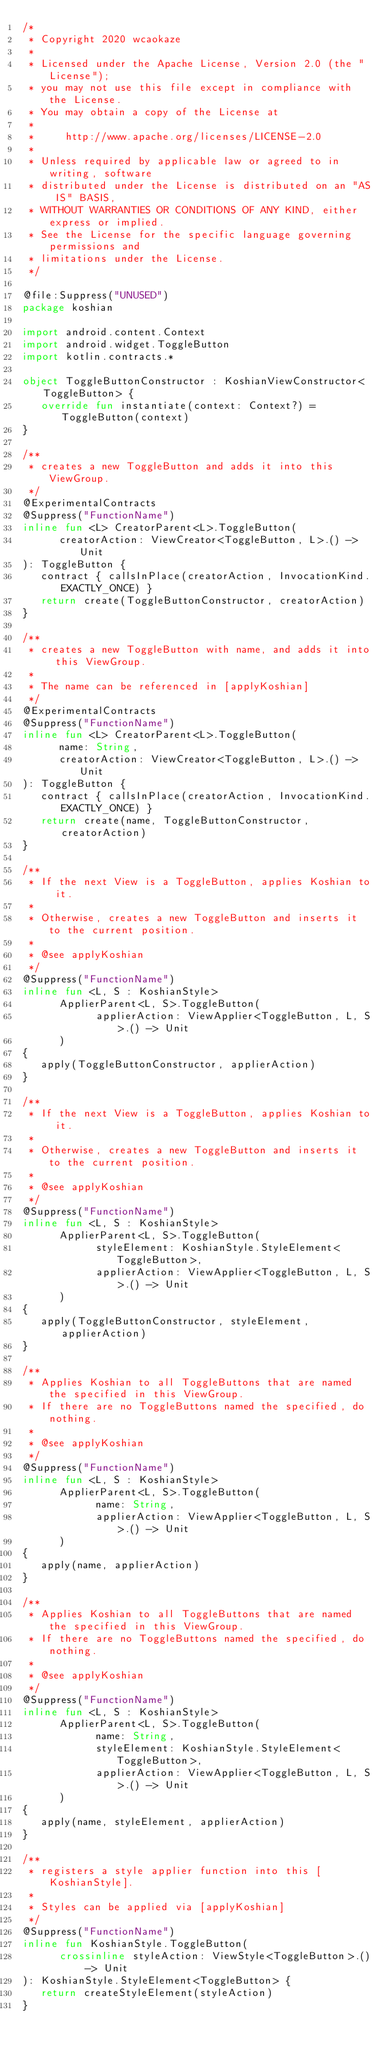<code> <loc_0><loc_0><loc_500><loc_500><_Kotlin_>/*
 * Copyright 2020 wcaokaze
 *
 * Licensed under the Apache License, Version 2.0 (the "License");
 * you may not use this file except in compliance with the License.
 * You may obtain a copy of the License at
 *
 *     http://www.apache.org/licenses/LICENSE-2.0
 *
 * Unless required by applicable law or agreed to in writing, software
 * distributed under the License is distributed on an "AS IS" BASIS,
 * WITHOUT WARRANTIES OR CONDITIONS OF ANY KIND, either express or implied.
 * See the License for the specific language governing permissions and
 * limitations under the License.
 */

@file:Suppress("UNUSED")
package koshian

import android.content.Context
import android.widget.ToggleButton
import kotlin.contracts.*

object ToggleButtonConstructor : KoshianViewConstructor<ToggleButton> {
   override fun instantiate(context: Context?) = ToggleButton(context)
}

/**
 * creates a new ToggleButton and adds it into this ViewGroup.
 */
@ExperimentalContracts
@Suppress("FunctionName")
inline fun <L> CreatorParent<L>.ToggleButton(
      creatorAction: ViewCreator<ToggleButton, L>.() -> Unit
): ToggleButton {
   contract { callsInPlace(creatorAction, InvocationKind.EXACTLY_ONCE) }
   return create(ToggleButtonConstructor, creatorAction)
}

/**
 * creates a new ToggleButton with name, and adds it into this ViewGroup.
 *
 * The name can be referenced in [applyKoshian]
 */
@ExperimentalContracts
@Suppress("FunctionName")
inline fun <L> CreatorParent<L>.ToggleButton(
      name: String,
      creatorAction: ViewCreator<ToggleButton, L>.() -> Unit
): ToggleButton {
   contract { callsInPlace(creatorAction, InvocationKind.EXACTLY_ONCE) }
   return create(name, ToggleButtonConstructor, creatorAction)
}

/**
 * If the next View is a ToggleButton, applies Koshian to it.
 *
 * Otherwise, creates a new ToggleButton and inserts it to the current position.
 *
 * @see applyKoshian
 */
@Suppress("FunctionName")
inline fun <L, S : KoshianStyle>
      ApplierParent<L, S>.ToggleButton(
            applierAction: ViewApplier<ToggleButton, L, S>.() -> Unit
      )
{
   apply(ToggleButtonConstructor, applierAction)
}

/**
 * If the next View is a ToggleButton, applies Koshian to it.
 *
 * Otherwise, creates a new ToggleButton and inserts it to the current position.
 *
 * @see applyKoshian
 */
@Suppress("FunctionName")
inline fun <L, S : KoshianStyle>
      ApplierParent<L, S>.ToggleButton(
            styleElement: KoshianStyle.StyleElement<ToggleButton>,
            applierAction: ViewApplier<ToggleButton, L, S>.() -> Unit
      )
{
   apply(ToggleButtonConstructor, styleElement, applierAction)
}

/**
 * Applies Koshian to all ToggleButtons that are named the specified in this ViewGroup.
 * If there are no ToggleButtons named the specified, do nothing.
 *
 * @see applyKoshian
 */
@Suppress("FunctionName")
inline fun <L, S : KoshianStyle>
      ApplierParent<L, S>.ToggleButton(
            name: String,
            applierAction: ViewApplier<ToggleButton, L, S>.() -> Unit
      )
{
   apply(name, applierAction)
}

/**
 * Applies Koshian to all ToggleButtons that are named the specified in this ViewGroup.
 * If there are no ToggleButtons named the specified, do nothing.
 *
 * @see applyKoshian
 */
@Suppress("FunctionName")
inline fun <L, S : KoshianStyle>
      ApplierParent<L, S>.ToggleButton(
            name: String,
            styleElement: KoshianStyle.StyleElement<ToggleButton>,
            applierAction: ViewApplier<ToggleButton, L, S>.() -> Unit
      )
{
   apply(name, styleElement, applierAction)
}

/**
 * registers a style applier function into this [KoshianStyle].
 *
 * Styles can be applied via [applyKoshian]
 */
@Suppress("FunctionName")
inline fun KoshianStyle.ToggleButton(
      crossinline styleAction: ViewStyle<ToggleButton>.() -> Unit
): KoshianStyle.StyleElement<ToggleButton> {
   return createStyleElement(styleAction)
}
</code> 